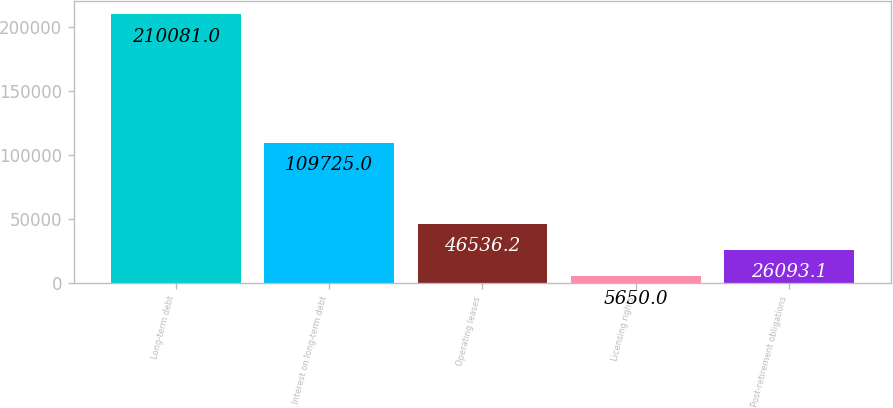Convert chart. <chart><loc_0><loc_0><loc_500><loc_500><bar_chart><fcel>Long-term debt<fcel>Interest on long-term debt<fcel>Operating leases<fcel>Licensing rights<fcel>Post-retirement obligations<nl><fcel>210081<fcel>109725<fcel>46536.2<fcel>5650<fcel>26093.1<nl></chart> 